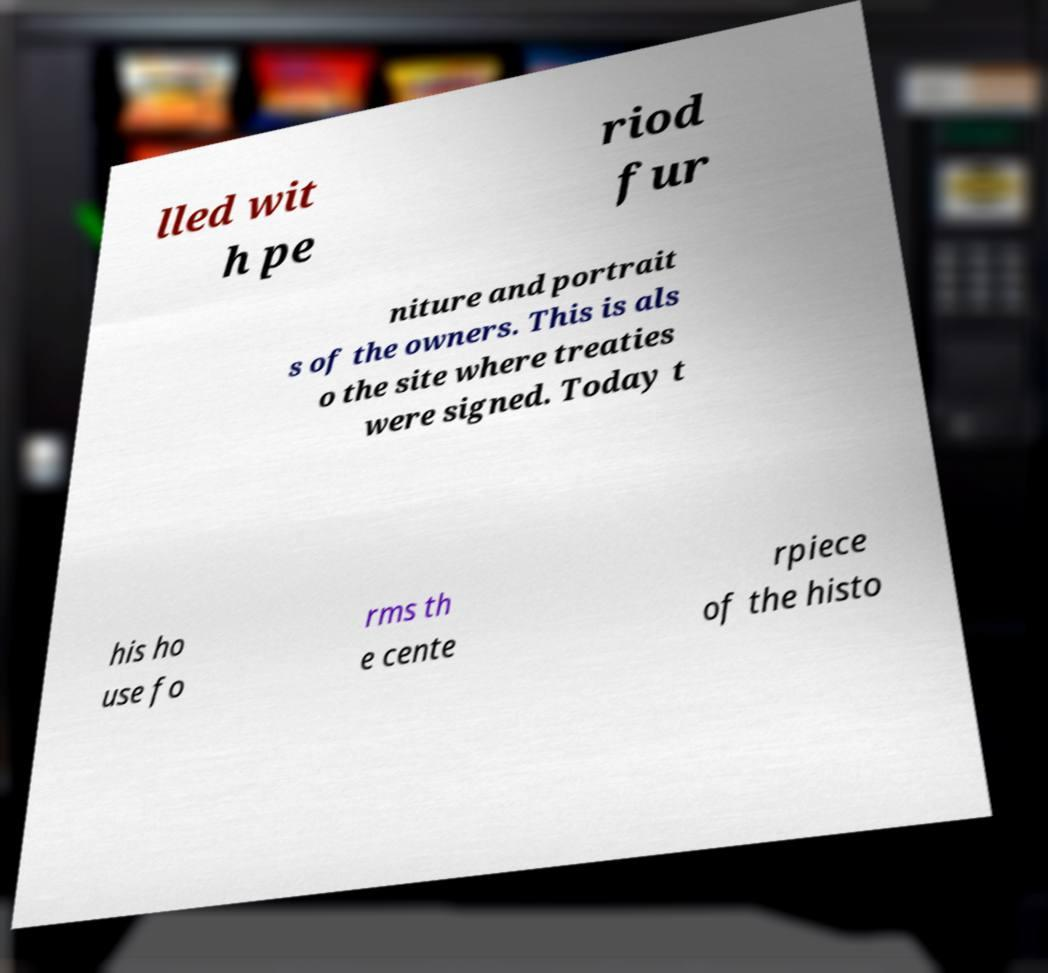Please identify and transcribe the text found in this image. lled wit h pe riod fur niture and portrait s of the owners. This is als o the site where treaties were signed. Today t his ho use fo rms th e cente rpiece of the histo 